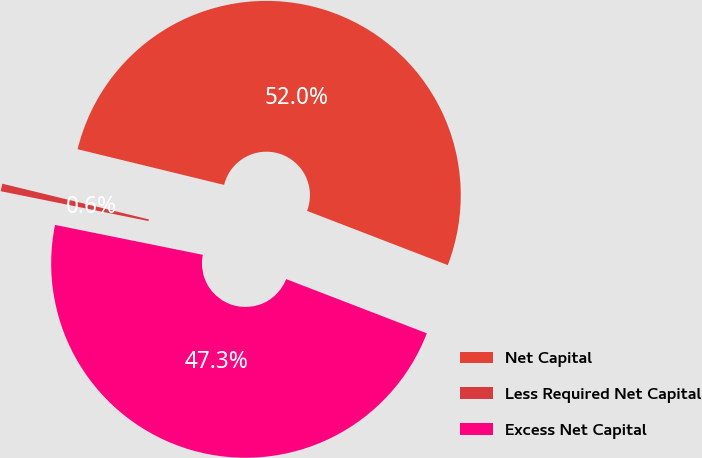Convert chart to OTSL. <chart><loc_0><loc_0><loc_500><loc_500><pie_chart><fcel>Net Capital<fcel>Less Required Net Capital<fcel>Excess Net Capital<nl><fcel>52.05%<fcel>0.63%<fcel>47.32%<nl></chart> 